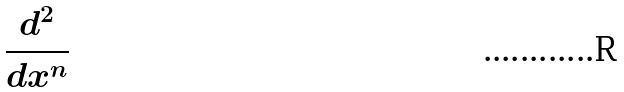Convert formula to latex. <formula><loc_0><loc_0><loc_500><loc_500>\frac { d ^ { 2 } } { d x ^ { n } }</formula> 